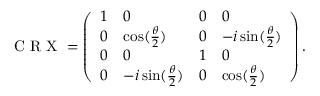<formula> <loc_0><loc_0><loc_500><loc_500>C R X = \left ( \begin{array} { l l l l } { 1 } & { 0 } & { 0 } & { 0 } \\ { 0 } & { \cos ( \frac { \theta } { 2 } ) } & { 0 } & { - i \sin ( \frac { \theta } { 2 } ) } \\ { 0 } & { 0 } & { 1 } & { 0 } \\ { 0 } & { - i \sin ( \frac { \theta } { 2 } ) } & { 0 } & { \cos ( \frac { \theta } { 2 } ) } \end{array} \right ) .</formula> 